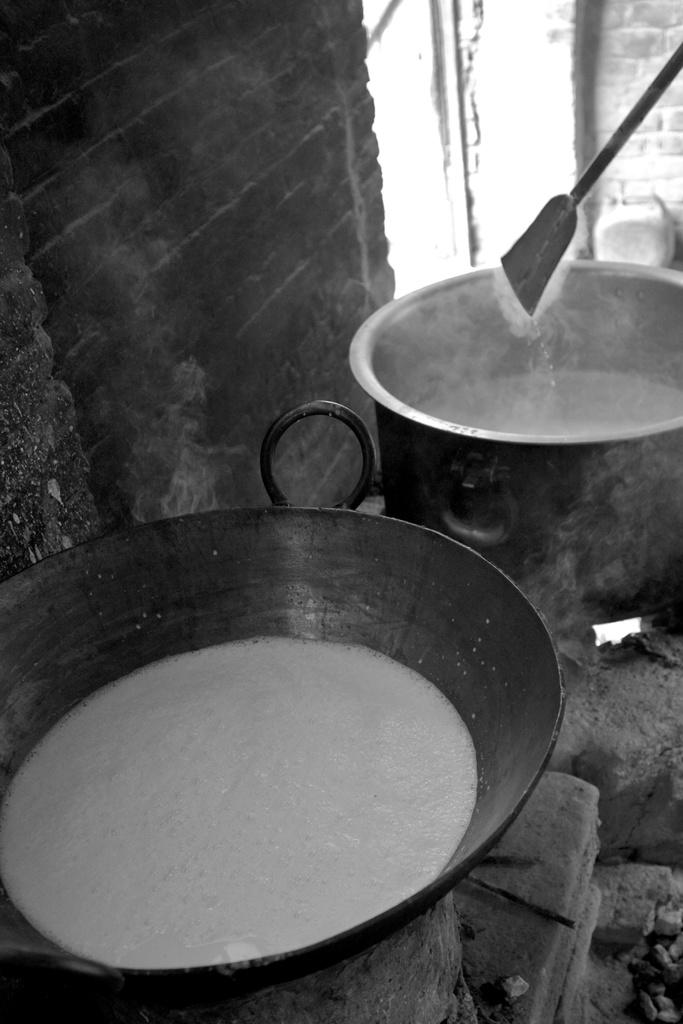How many vessels can be seen in the image? There are two vessels in the image. What is happening to the food in the vessels? Food is being cooked in the vessels. Where are the vessels placed? The vessels are placed on a brick stove. What is the background of the image made of? There is a brick wall behind the vessels. What type of iron is being used to test the food in the image? There is no iron or testing of food present in the image; it shows vessels with food being cooked on a brick stove. 